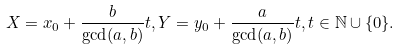Convert formula to latex. <formula><loc_0><loc_0><loc_500><loc_500>X = x _ { 0 } + \frac { b } { \gcd ( a , b ) } t , Y = y _ { 0 } + \frac { a } { \gcd ( a , b ) } t , t \in \mathbb { N } \cup \{ 0 \} .</formula> 